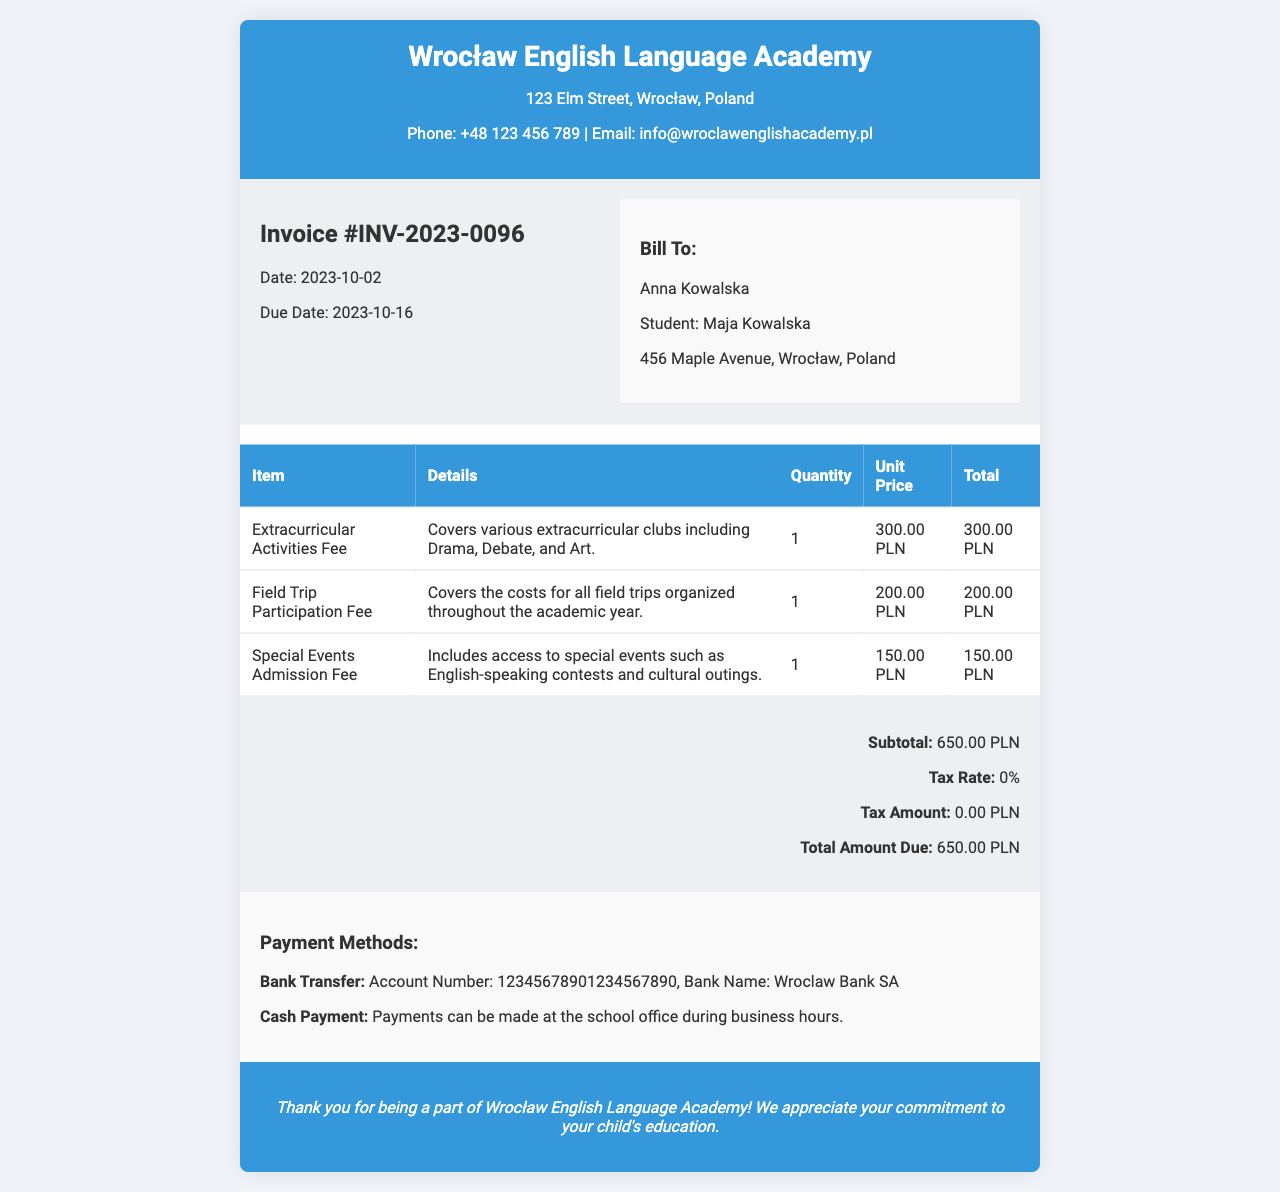What is the invoice number? The invoice number is specified in the document details section, which identifies this particular invoice.
Answer: INV-2023-0096 Who is the invoice addressed to? The recipient's name is provided in the billing section, showing who the invoice is for.
Answer: Anna Kowalska What is the total amount due? The total amount due is calculated by summing all relevant fees, which is stated in the summary section.
Answer: 650.00 PLN What is included in the extracurricular activities fee? The description in the table provides information on what activities are covered by this fee.
Answer: Various extracurricular clubs including Drama, Debate, and Art When is the due date for payment? The due date for payment is indicated in the document details section, which sets a deadline for payment.
Answer: 2023-10-16 How much is the field trip participation fee? The fee for field trip participation is listed in the itemized table with its corresponding total.
Answer: 200.00 PLN What payment methods are accepted? The document specifies the payment options available, detailing how payments can be made.
Answer: Bank Transfer, Cash Payment What is the subtotal for the invoice? The subtotal is the sum of individual costs before tax, shown in the summary section.
Answer: 650.00 PLN What is the address of the English language academy? The academy's address is listed in the header section of the invoice.
Answer: 123 Elm Street, Wrocław, Poland 